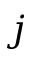<formula> <loc_0><loc_0><loc_500><loc_500>j</formula> 